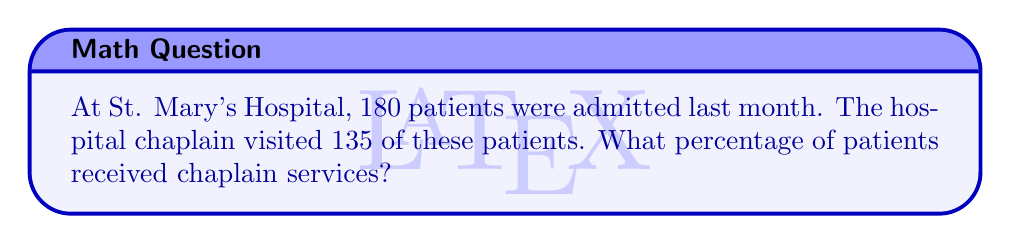Give your solution to this math problem. To calculate the percentage of patients who received chaplain services, we need to follow these steps:

1. Identify the total number of patients: 180
2. Identify the number of patients who received chaplain services: 135
3. Use the formula for percentage: $\text{Percentage} = \frac{\text{Part}}{\text{Whole}} \times 100\%$

Let's plug in our numbers:

$$\text{Percentage} = \frac{135}{180} \times 100\%$$

Now, let's solve this step-by-step:

4. Simplify the fraction:
   $$\frac{135}{180} = \frac{3}{4}$$

5. Convert the fraction to a decimal:
   $$\frac{3}{4} = 0.75$$

6. Multiply by 100% to get the percentage:
   $$0.75 \times 100\% = 75\%$$

Therefore, 75% of patients at St. Mary's Hospital received chaplain services last month.
Answer: 75% 